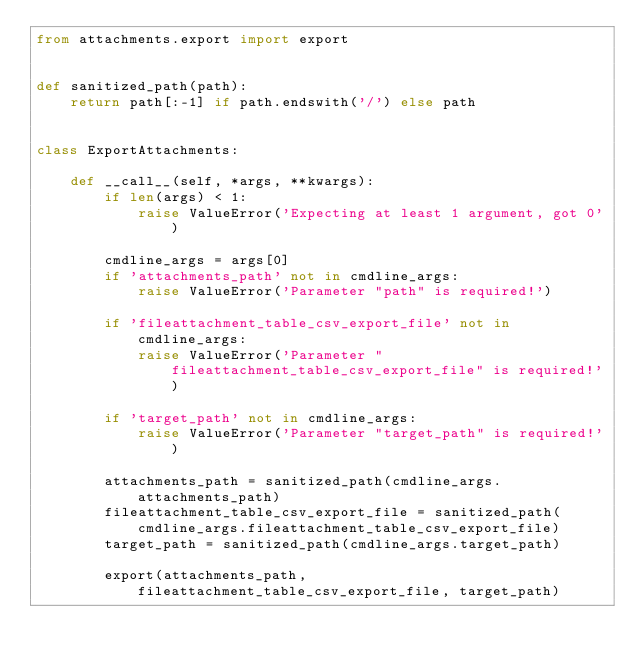<code> <loc_0><loc_0><loc_500><loc_500><_Python_>from attachments.export import export


def sanitized_path(path):
    return path[:-1] if path.endswith('/') else path


class ExportAttachments:

    def __call__(self, *args, **kwargs):
        if len(args) < 1:
            raise ValueError('Expecting at least 1 argument, got 0')

        cmdline_args = args[0]
        if 'attachments_path' not in cmdline_args:
            raise ValueError('Parameter "path" is required!')

        if 'fileattachment_table_csv_export_file' not in cmdline_args:
            raise ValueError('Parameter "fileattachment_table_csv_export_file" is required!')

        if 'target_path' not in cmdline_args:
            raise ValueError('Parameter "target_path" is required!')

        attachments_path = sanitized_path(cmdline_args.attachments_path)
        fileattachment_table_csv_export_file = sanitized_path(cmdline_args.fileattachment_table_csv_export_file)
        target_path = sanitized_path(cmdline_args.target_path)

        export(attachments_path, fileattachment_table_csv_export_file, target_path)
</code> 